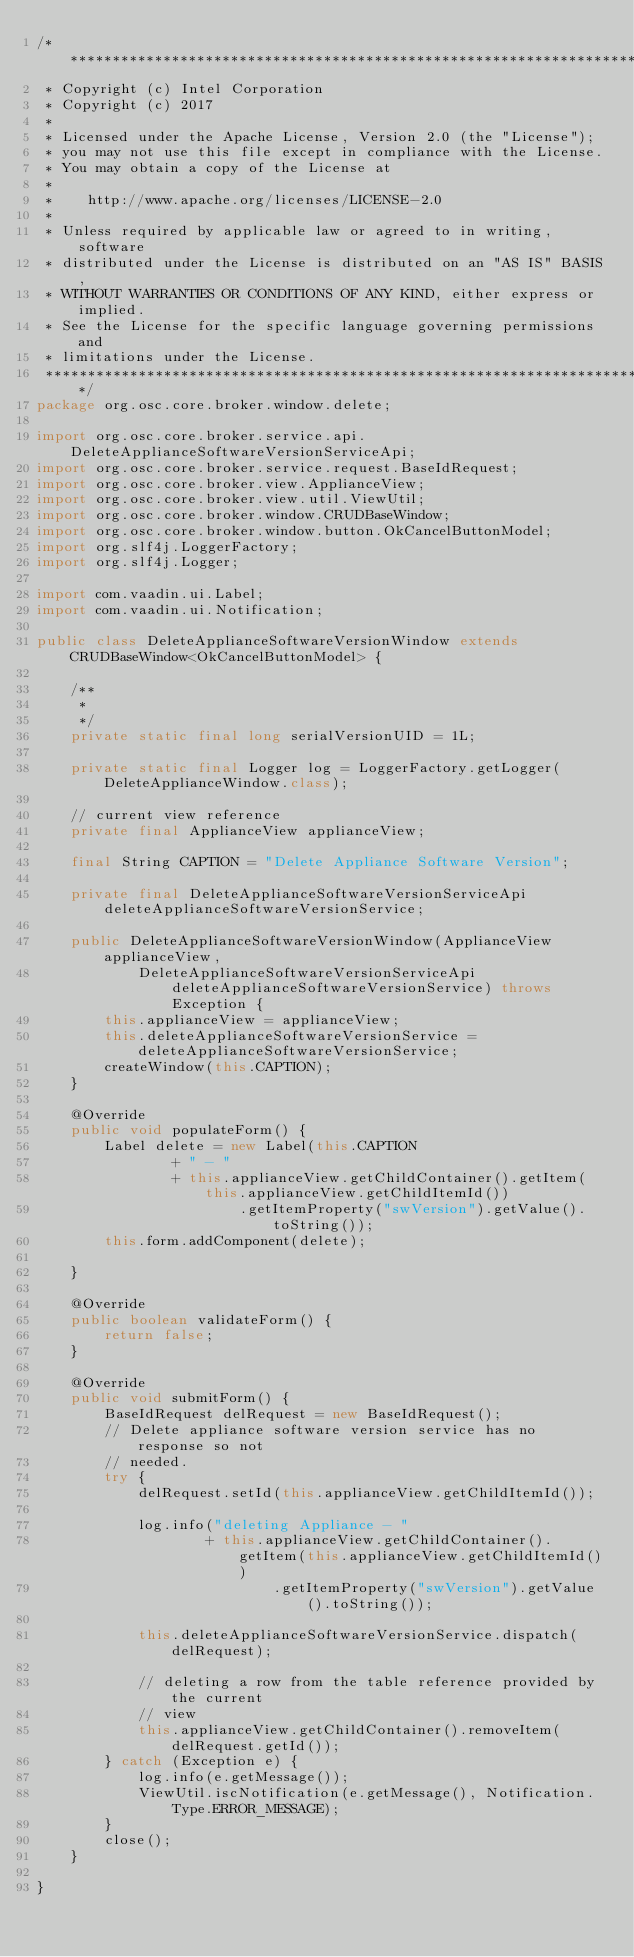<code> <loc_0><loc_0><loc_500><loc_500><_Java_>/*******************************************************************************
 * Copyright (c) Intel Corporation
 * Copyright (c) 2017
 *
 * Licensed under the Apache License, Version 2.0 (the "License");
 * you may not use this file except in compliance with the License.
 * You may obtain a copy of the License at
 *
 *    http://www.apache.org/licenses/LICENSE-2.0
 *
 * Unless required by applicable law or agreed to in writing, software
 * distributed under the License is distributed on an "AS IS" BASIS,
 * WITHOUT WARRANTIES OR CONDITIONS OF ANY KIND, either express or implied.
 * See the License for the specific language governing permissions and
 * limitations under the License.
 *******************************************************************************/
package org.osc.core.broker.window.delete;

import org.osc.core.broker.service.api.DeleteApplianceSoftwareVersionServiceApi;
import org.osc.core.broker.service.request.BaseIdRequest;
import org.osc.core.broker.view.ApplianceView;
import org.osc.core.broker.view.util.ViewUtil;
import org.osc.core.broker.window.CRUDBaseWindow;
import org.osc.core.broker.window.button.OkCancelButtonModel;
import org.slf4j.LoggerFactory;
import org.slf4j.Logger;

import com.vaadin.ui.Label;
import com.vaadin.ui.Notification;

public class DeleteApplianceSoftwareVersionWindow extends CRUDBaseWindow<OkCancelButtonModel> {

    /**
     *
     */
    private static final long serialVersionUID = 1L;

    private static final Logger log = LoggerFactory.getLogger(DeleteApplianceWindow.class);

    // current view reference
    private final ApplianceView applianceView;

    final String CAPTION = "Delete Appliance Software Version";

    private final DeleteApplianceSoftwareVersionServiceApi deleteApplianceSoftwareVersionService;

    public DeleteApplianceSoftwareVersionWindow(ApplianceView applianceView,
            DeleteApplianceSoftwareVersionServiceApi deleteApplianceSoftwareVersionService) throws Exception {
        this.applianceView = applianceView;
        this.deleteApplianceSoftwareVersionService = deleteApplianceSoftwareVersionService;
        createWindow(this.CAPTION);
    }

    @Override
    public void populateForm() {
        Label delete = new Label(this.CAPTION
                + " - "
                + this.applianceView.getChildContainer().getItem(this.applianceView.getChildItemId())
                        .getItemProperty("swVersion").getValue().toString());
        this.form.addComponent(delete);

    }

    @Override
    public boolean validateForm() {
        return false;
    }

    @Override
    public void submitForm() {
        BaseIdRequest delRequest = new BaseIdRequest();
        // Delete appliance software version service has no response so not
        // needed.
        try {
            delRequest.setId(this.applianceView.getChildItemId());

            log.info("deleting Appliance - "
                    + this.applianceView.getChildContainer().getItem(this.applianceView.getChildItemId())
                            .getItemProperty("swVersion").getValue().toString());

            this.deleteApplianceSoftwareVersionService.dispatch(delRequest);

            // deleting a row from the table reference provided by the current
            // view
            this.applianceView.getChildContainer().removeItem(delRequest.getId());
        } catch (Exception e) {
            log.info(e.getMessage());
            ViewUtil.iscNotification(e.getMessage(), Notification.Type.ERROR_MESSAGE);
        }
        close();
    }

}
</code> 